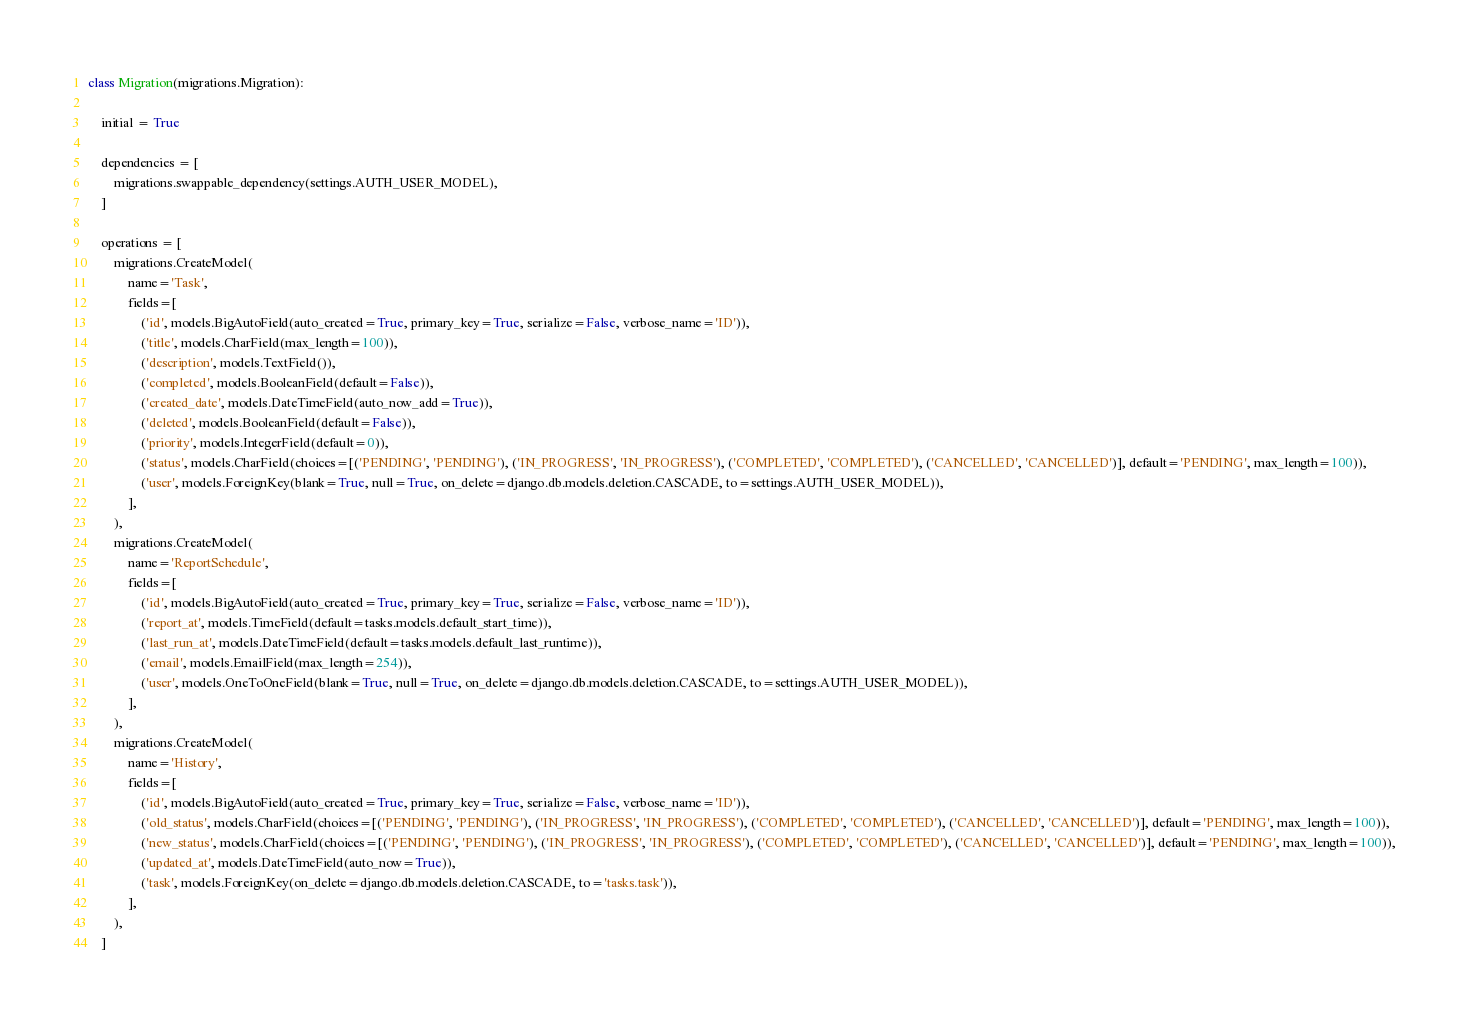<code> <loc_0><loc_0><loc_500><loc_500><_Python_>
class Migration(migrations.Migration):

    initial = True

    dependencies = [
        migrations.swappable_dependency(settings.AUTH_USER_MODEL),
    ]

    operations = [
        migrations.CreateModel(
            name='Task',
            fields=[
                ('id', models.BigAutoField(auto_created=True, primary_key=True, serialize=False, verbose_name='ID')),
                ('title', models.CharField(max_length=100)),
                ('description', models.TextField()),
                ('completed', models.BooleanField(default=False)),
                ('created_date', models.DateTimeField(auto_now_add=True)),
                ('deleted', models.BooleanField(default=False)),
                ('priority', models.IntegerField(default=0)),
                ('status', models.CharField(choices=[('PENDING', 'PENDING'), ('IN_PROGRESS', 'IN_PROGRESS'), ('COMPLETED', 'COMPLETED'), ('CANCELLED', 'CANCELLED')], default='PENDING', max_length=100)),
                ('user', models.ForeignKey(blank=True, null=True, on_delete=django.db.models.deletion.CASCADE, to=settings.AUTH_USER_MODEL)),
            ],
        ),
        migrations.CreateModel(
            name='ReportSchedule',
            fields=[
                ('id', models.BigAutoField(auto_created=True, primary_key=True, serialize=False, verbose_name='ID')),
                ('report_at', models.TimeField(default=tasks.models.default_start_time)),
                ('last_run_at', models.DateTimeField(default=tasks.models.default_last_runtime)),
                ('email', models.EmailField(max_length=254)),
                ('user', models.OneToOneField(blank=True, null=True, on_delete=django.db.models.deletion.CASCADE, to=settings.AUTH_USER_MODEL)),
            ],
        ),
        migrations.CreateModel(
            name='History',
            fields=[
                ('id', models.BigAutoField(auto_created=True, primary_key=True, serialize=False, verbose_name='ID')),
                ('old_status', models.CharField(choices=[('PENDING', 'PENDING'), ('IN_PROGRESS', 'IN_PROGRESS'), ('COMPLETED', 'COMPLETED'), ('CANCELLED', 'CANCELLED')], default='PENDING', max_length=100)),
                ('new_status', models.CharField(choices=[('PENDING', 'PENDING'), ('IN_PROGRESS', 'IN_PROGRESS'), ('COMPLETED', 'COMPLETED'), ('CANCELLED', 'CANCELLED')], default='PENDING', max_length=100)),
                ('updated_at', models.DateTimeField(auto_now=True)),
                ('task', models.ForeignKey(on_delete=django.db.models.deletion.CASCADE, to='tasks.task')),
            ],
        ),
    ]
</code> 